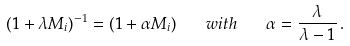Convert formula to latex. <formula><loc_0><loc_0><loc_500><loc_500>( 1 + \lambda M _ { i } ) ^ { - 1 } = ( 1 + \alpha M _ { i } ) \quad w i t h \quad \alpha = \frac { \lambda } { \lambda - 1 } \, .</formula> 